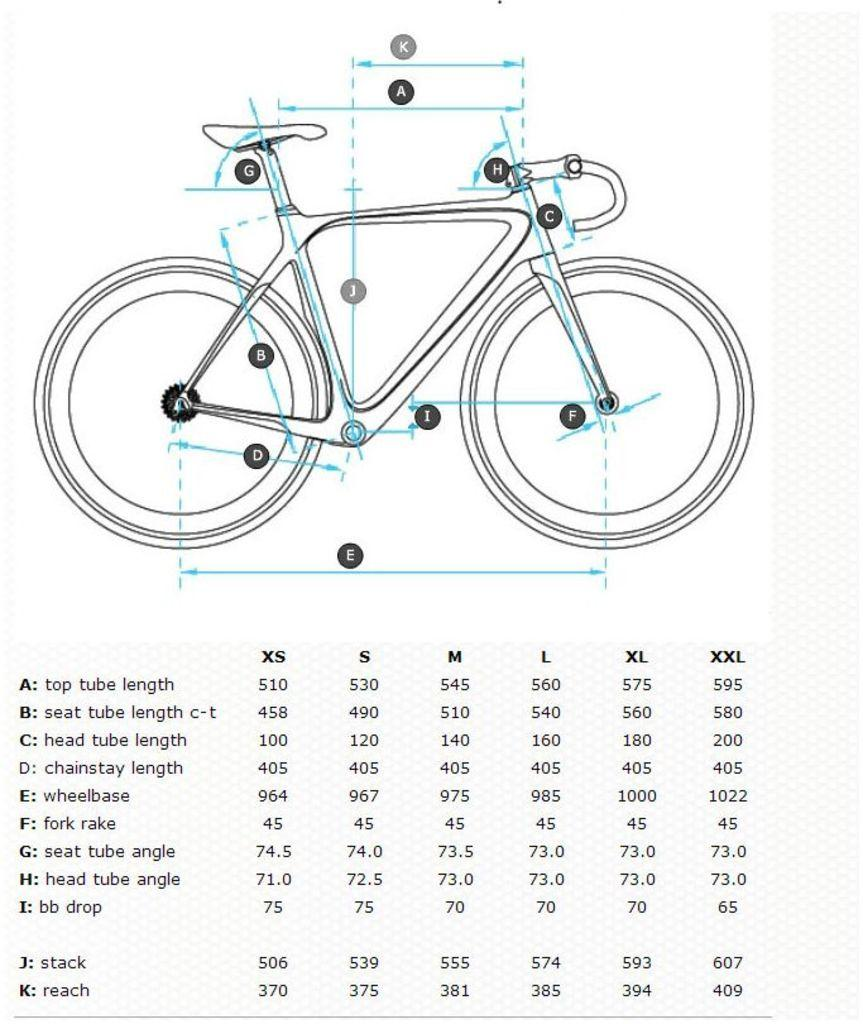<image>
Summarize the visual content of the image. a diagram of a bike that indicates top tube length measurements 